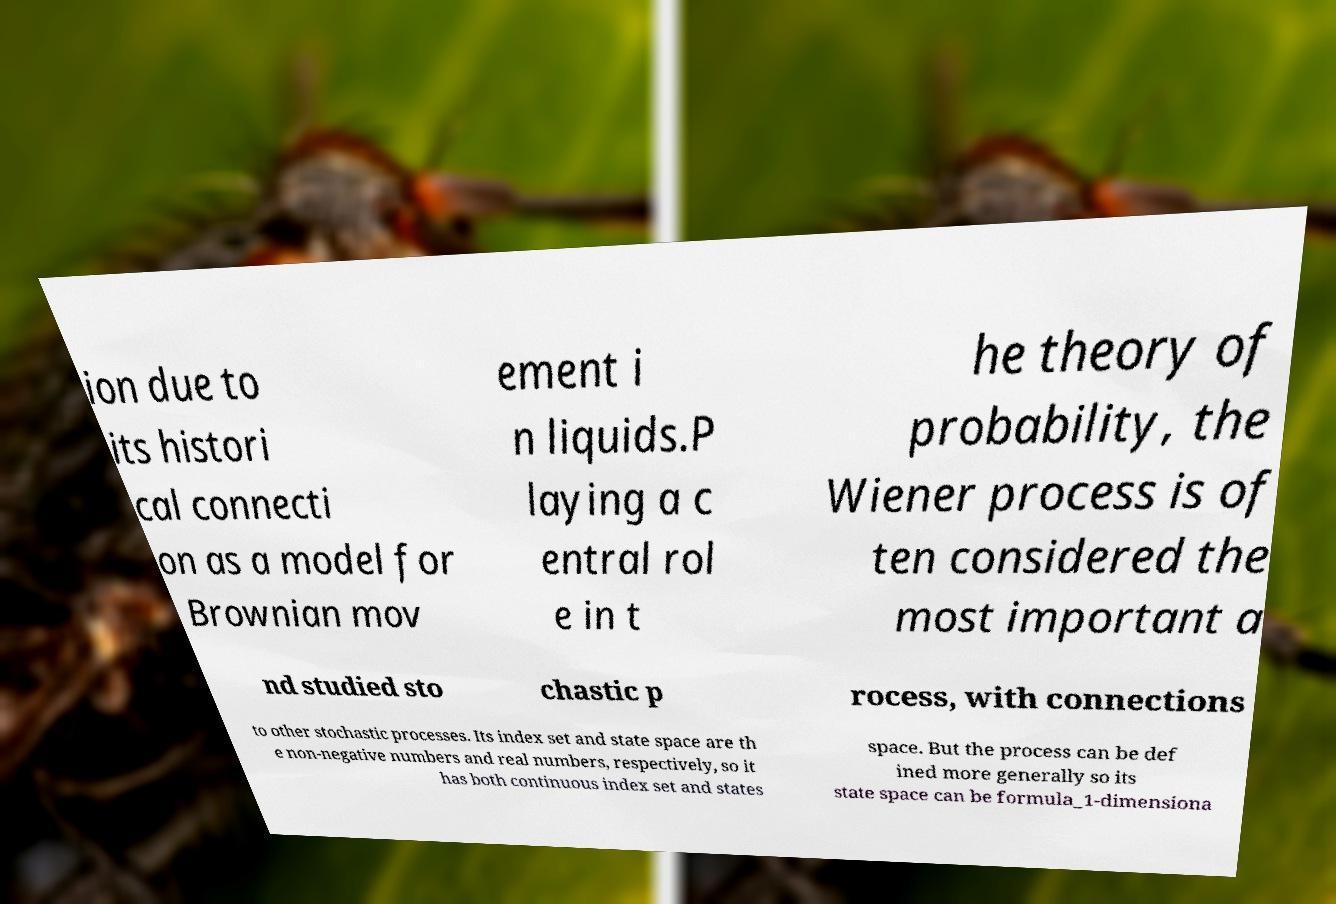Can you accurately transcribe the text from the provided image for me? ion due to its histori cal connecti on as a model for Brownian mov ement i n liquids.P laying a c entral rol e in t he theory of probability, the Wiener process is of ten considered the most important a nd studied sto chastic p rocess, with connections to other stochastic processes. Its index set and state space are th e non-negative numbers and real numbers, respectively, so it has both continuous index set and states space. But the process can be def ined more generally so its state space can be formula_1-dimensiona 